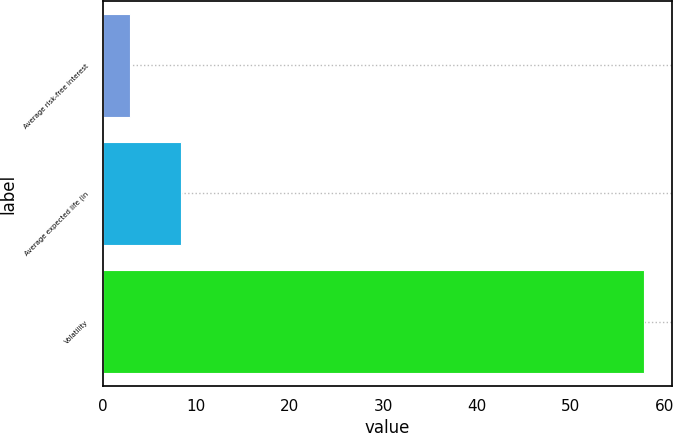Convert chart. <chart><loc_0><loc_0><loc_500><loc_500><bar_chart><fcel>Average risk-free interest<fcel>Average expected life (in<fcel>Volatility<nl><fcel>2.9<fcel>8.4<fcel>57.9<nl></chart> 